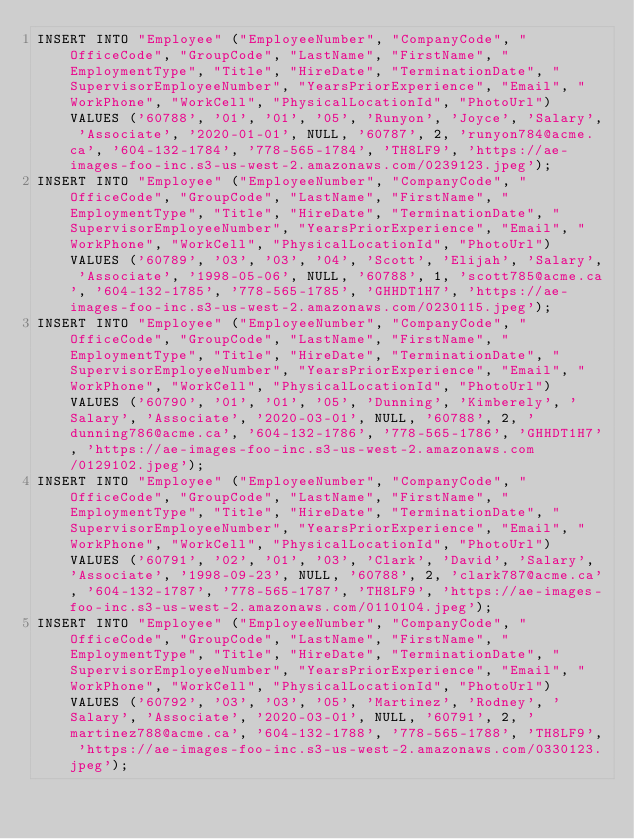<code> <loc_0><loc_0><loc_500><loc_500><_SQL_>INSERT INTO "Employee" ("EmployeeNumber", "CompanyCode", "OfficeCode", "GroupCode", "LastName", "FirstName", "EmploymentType", "Title", "HireDate", "TerminationDate", "SupervisorEmployeeNumber", "YearsPriorExperience", "Email", "WorkPhone", "WorkCell", "PhysicalLocationId", "PhotoUrl") VALUES ('60788', '01', '01', '05', 'Runyon', 'Joyce', 'Salary', 'Associate', '2020-01-01', NULL, '60787', 2, 'runyon784@acme.ca', '604-132-1784', '778-565-1784', 'TH8LF9', 'https://ae-images-foo-inc.s3-us-west-2.amazonaws.com/0239123.jpeg');
INSERT INTO "Employee" ("EmployeeNumber", "CompanyCode", "OfficeCode", "GroupCode", "LastName", "FirstName", "EmploymentType", "Title", "HireDate", "TerminationDate", "SupervisorEmployeeNumber", "YearsPriorExperience", "Email", "WorkPhone", "WorkCell", "PhysicalLocationId", "PhotoUrl") VALUES ('60789', '03', '03', '04', 'Scott', 'Elijah', 'Salary', 'Associate', '1998-05-06', NULL, '60788', 1, 'scott785@acme.ca', '604-132-1785', '778-565-1785', 'GHHDT1H7', 'https://ae-images-foo-inc.s3-us-west-2.amazonaws.com/0230115.jpeg');
INSERT INTO "Employee" ("EmployeeNumber", "CompanyCode", "OfficeCode", "GroupCode", "LastName", "FirstName", "EmploymentType", "Title", "HireDate", "TerminationDate", "SupervisorEmployeeNumber", "YearsPriorExperience", "Email", "WorkPhone", "WorkCell", "PhysicalLocationId", "PhotoUrl") VALUES ('60790', '01', '01', '05', 'Dunning', 'Kimberely', 'Salary', 'Associate', '2020-03-01', NULL, '60788', 2, 'dunning786@acme.ca', '604-132-1786', '778-565-1786', 'GHHDT1H7', 'https://ae-images-foo-inc.s3-us-west-2.amazonaws.com/0129102.jpeg');
INSERT INTO "Employee" ("EmployeeNumber", "CompanyCode", "OfficeCode", "GroupCode", "LastName", "FirstName", "EmploymentType", "Title", "HireDate", "TerminationDate", "SupervisorEmployeeNumber", "YearsPriorExperience", "Email", "WorkPhone", "WorkCell", "PhysicalLocationId", "PhotoUrl") VALUES ('60791', '02', '01', '03', 'Clark', 'David', 'Salary', 'Associate', '1998-09-23', NULL, '60788', 2, 'clark787@acme.ca', '604-132-1787', '778-565-1787', 'TH8LF9', 'https://ae-images-foo-inc.s3-us-west-2.amazonaws.com/0110104.jpeg');
INSERT INTO "Employee" ("EmployeeNumber", "CompanyCode", "OfficeCode", "GroupCode", "LastName", "FirstName", "EmploymentType", "Title", "HireDate", "TerminationDate", "SupervisorEmployeeNumber", "YearsPriorExperience", "Email", "WorkPhone", "WorkCell", "PhysicalLocationId", "PhotoUrl") VALUES ('60792', '03', '03', '05', 'Martinez', 'Rodney', 'Salary', 'Associate', '2020-03-01', NULL, '60791', 2, 'martinez788@acme.ca', '604-132-1788', '778-565-1788', 'TH8LF9', 'https://ae-images-foo-inc.s3-us-west-2.amazonaws.com/0330123.jpeg');</code> 